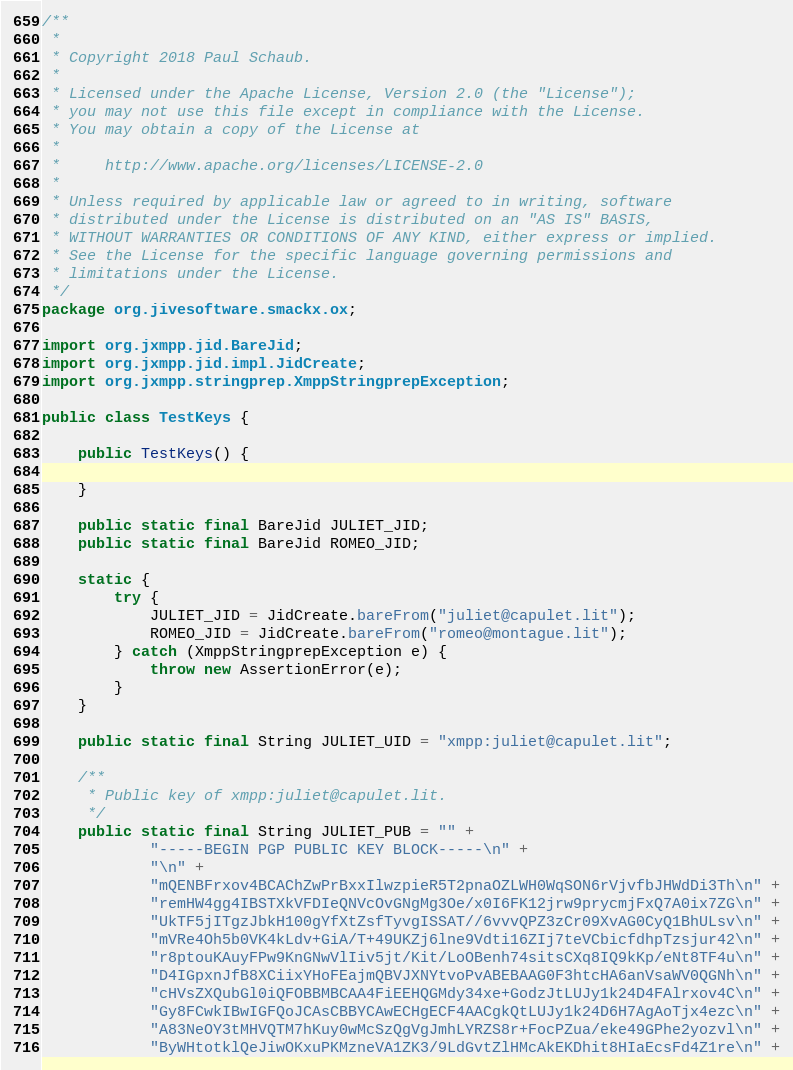Convert code to text. <code><loc_0><loc_0><loc_500><loc_500><_Java_>/**
 *
 * Copyright 2018 Paul Schaub.
 *
 * Licensed under the Apache License, Version 2.0 (the "License");
 * you may not use this file except in compliance with the License.
 * You may obtain a copy of the License at
 *
 *     http://www.apache.org/licenses/LICENSE-2.0
 *
 * Unless required by applicable law or agreed to in writing, software
 * distributed under the License is distributed on an "AS IS" BASIS,
 * WITHOUT WARRANTIES OR CONDITIONS OF ANY KIND, either express or implied.
 * See the License for the specific language governing permissions and
 * limitations under the License.
 */
package org.jivesoftware.smackx.ox;

import org.jxmpp.jid.BareJid;
import org.jxmpp.jid.impl.JidCreate;
import org.jxmpp.stringprep.XmppStringprepException;

public class TestKeys {

    public TestKeys() {

    }

    public static final BareJid JULIET_JID;
    public static final BareJid ROMEO_JID;

    static {
        try {
            JULIET_JID = JidCreate.bareFrom("juliet@capulet.lit");
            ROMEO_JID = JidCreate.bareFrom("romeo@montague.lit");
        } catch (XmppStringprepException e) {
            throw new AssertionError(e);
        }
    }

    public static final String JULIET_UID = "xmpp:juliet@capulet.lit";

    /**
     * Public key of xmpp:juliet@capulet.lit.
     */
    public static final String JULIET_PUB = "" +
            "-----BEGIN PGP PUBLIC KEY BLOCK-----\n" +
            "\n" +
            "mQENBFrxov4BCAChZwPrBxxIlwzpieR5T2pnaOZLWH0WqSON6rVjvfbJHWdDi3Th\n" +
            "remHW4gg4IBSTXkVFDIeQNVcOvGNgMg3Oe/x0I6FK12jrw9prycmjFxQ7A0ix7ZG\n" +
            "UkTF5jITgzJbkH100gYfXtZsfTyvgISSAT//6vvvQPZ3zCr09XvAG0CyQ1BhULsv\n" +
            "mVRe4Oh5b0VK4kLdv+GiA/T+49UKZj6lne9Vdti16ZIj7teVCbicfdhpTzsjur42\n" +
            "r8ptouKAuyFPw9KnGNwVlIiv5jt/Kit/LoOBenh74sitsCXq8IQ9kKp/eNt8TF4u\n" +
            "D4IGpxnJfB8XCiixYHoFEajmQBVJXNYtvoPvABEBAAG0F3htcHA6anVsaWV0QGNh\n" +
            "cHVsZXQubGl0iQFOBBMBCAA4FiEEHQGMdy34xe+GodzJtLUJy1k24D4FAlrxov4C\n" +
            "Gy8FCwkIBwIGFQoJCAsCBBYCAwECHgECF4AACgkQtLUJy1k24D6H7AgAoTjx4ezc\n" +
            "A83NeOY3tMHVQTM7hKuy0wMcSzQgVgJmhLYRZS8r+FocPZua/eke49GPhe2yozvl\n" +
            "ByWHtotklQeJiwOKxuPKMzneVA1ZK3/9LdGvtZlHMcAkEKDhit8HIaEcsFd4Z1re\n" +</code> 